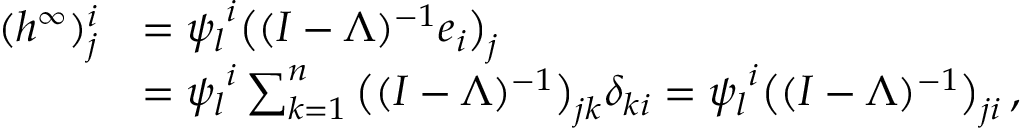Convert formula to latex. <formula><loc_0><loc_0><loc_500><loc_500>\begin{array} { r l } { ( { h ^ { \infty } } ) _ { j } ^ { i } } & { = { \psi _ { l } } ^ { i } \left ( ( I - \Lambda ) ^ { - 1 } e _ { i } \right ) _ { j } } \\ & { = { \psi _ { l } } ^ { i } \sum _ { k = 1 } ^ { n } \left ( ( I - \Lambda ) ^ { - 1 } \right ) _ { j k } \delta _ { k i } = { \psi _ { l } } ^ { i } \left ( ( I - \Lambda ) ^ { - 1 } \right ) _ { j i } \, , } \end{array}</formula> 